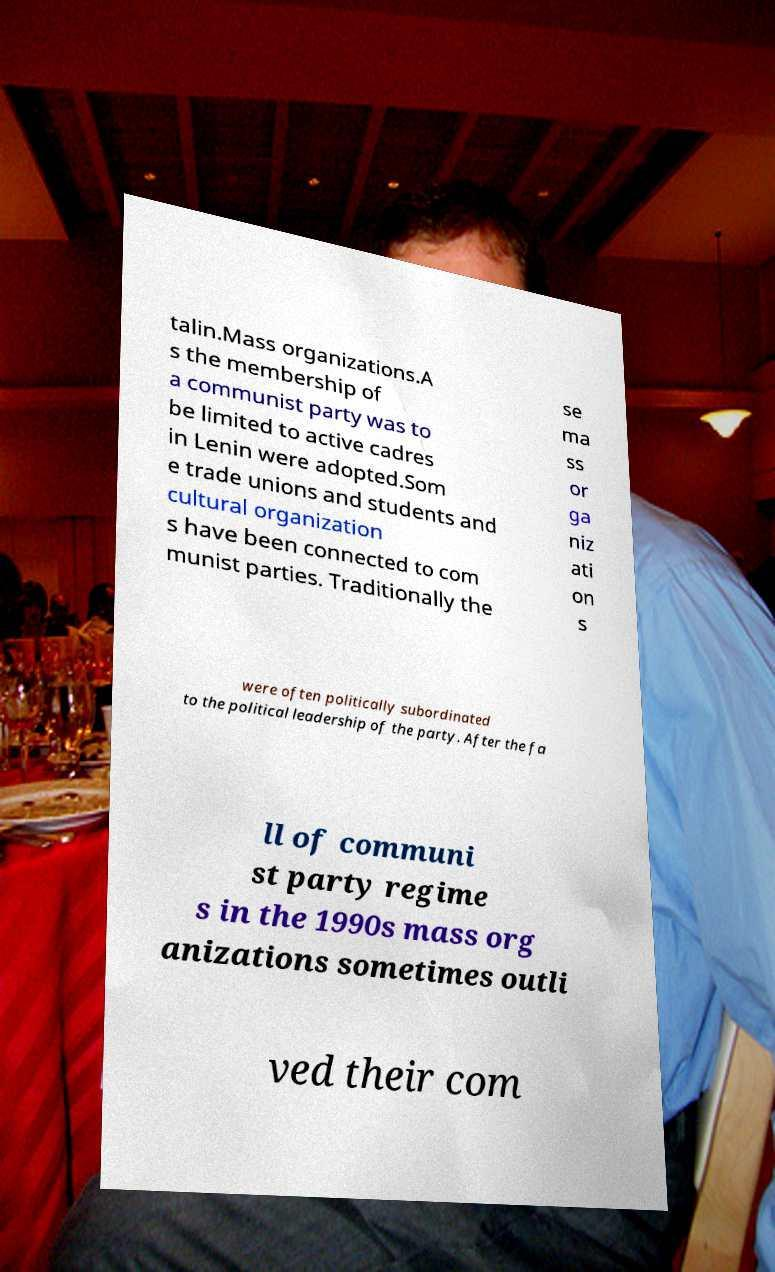I need the written content from this picture converted into text. Can you do that? talin.Mass organizations.A s the membership of a communist party was to be limited to active cadres in Lenin were adopted.Som e trade unions and students and cultural organization s have been connected to com munist parties. Traditionally the se ma ss or ga niz ati on s were often politically subordinated to the political leadership of the party. After the fa ll of communi st party regime s in the 1990s mass org anizations sometimes outli ved their com 